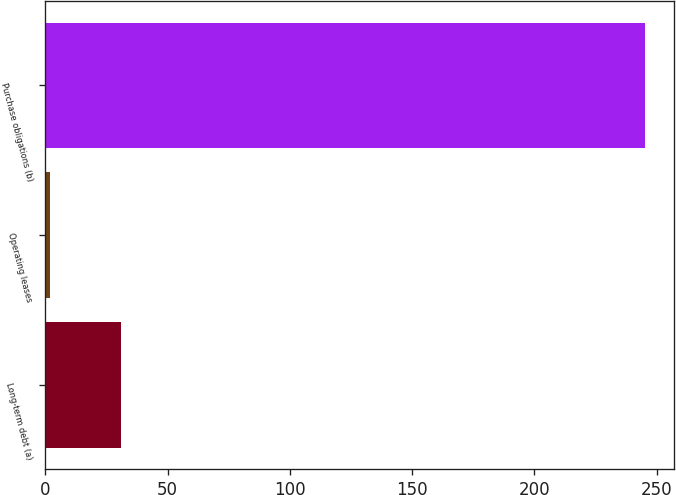Convert chart. <chart><loc_0><loc_0><loc_500><loc_500><bar_chart><fcel>Long-term debt (a)<fcel>Operating leases<fcel>Purchase obligations (b)<nl><fcel>31<fcel>2<fcel>245<nl></chart> 